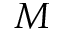Convert formula to latex. <formula><loc_0><loc_0><loc_500><loc_500>M</formula> 